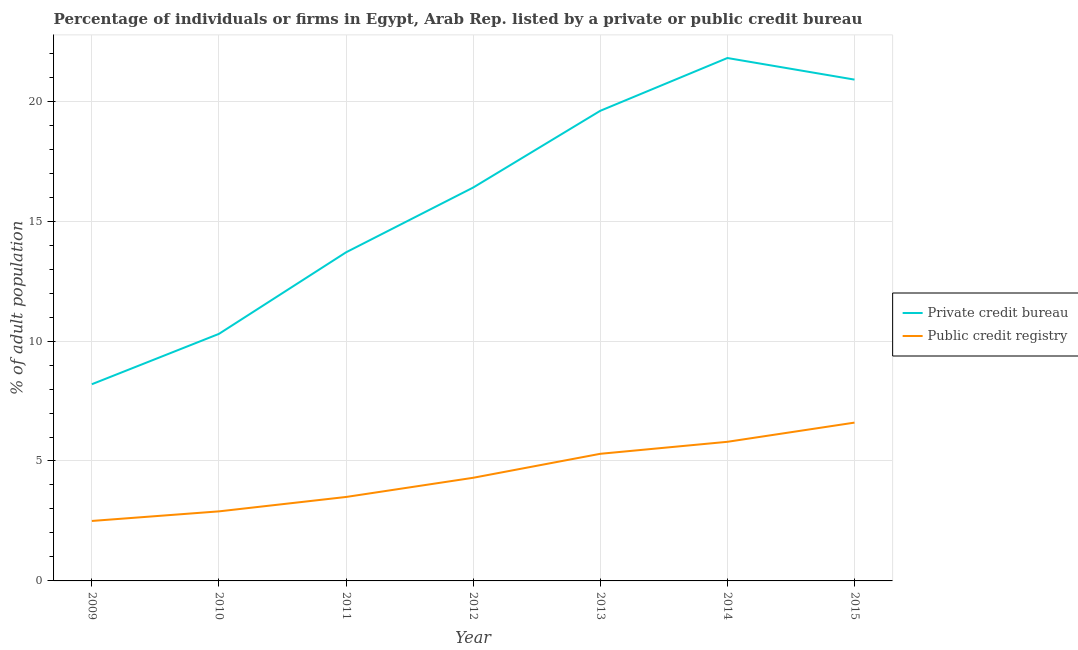Is the number of lines equal to the number of legend labels?
Offer a very short reply. Yes. What is the percentage of firms listed by private credit bureau in 2015?
Ensure brevity in your answer.  20.9. Across all years, what is the maximum percentage of firms listed by private credit bureau?
Your response must be concise. 21.8. In which year was the percentage of firms listed by private credit bureau maximum?
Make the answer very short. 2014. In which year was the percentage of firms listed by private credit bureau minimum?
Your answer should be very brief. 2009. What is the total percentage of firms listed by public credit bureau in the graph?
Provide a succinct answer. 30.9. What is the difference between the percentage of firms listed by private credit bureau in 2009 and the percentage of firms listed by public credit bureau in 2010?
Provide a succinct answer. 5.3. What is the average percentage of firms listed by private credit bureau per year?
Make the answer very short. 15.84. In the year 2010, what is the difference between the percentage of firms listed by private credit bureau and percentage of firms listed by public credit bureau?
Give a very brief answer. 7.4. In how many years, is the percentage of firms listed by public credit bureau greater than 1 %?
Provide a succinct answer. 7. What is the ratio of the percentage of firms listed by private credit bureau in 2014 to that in 2015?
Your answer should be compact. 1.04. Is the difference between the percentage of firms listed by private credit bureau in 2009 and 2015 greater than the difference between the percentage of firms listed by public credit bureau in 2009 and 2015?
Provide a succinct answer. No. What is the difference between the highest and the second highest percentage of firms listed by private credit bureau?
Your answer should be compact. 0.9. What is the difference between the highest and the lowest percentage of firms listed by private credit bureau?
Provide a short and direct response. 13.6. In how many years, is the percentage of firms listed by private credit bureau greater than the average percentage of firms listed by private credit bureau taken over all years?
Your answer should be very brief. 4. Is the percentage of firms listed by private credit bureau strictly greater than the percentage of firms listed by public credit bureau over the years?
Offer a terse response. Yes. Are the values on the major ticks of Y-axis written in scientific E-notation?
Your answer should be very brief. No. Does the graph contain any zero values?
Ensure brevity in your answer.  No. How are the legend labels stacked?
Your answer should be very brief. Vertical. What is the title of the graph?
Offer a very short reply. Percentage of individuals or firms in Egypt, Arab Rep. listed by a private or public credit bureau. What is the label or title of the X-axis?
Offer a terse response. Year. What is the label or title of the Y-axis?
Your answer should be very brief. % of adult population. What is the % of adult population of Private credit bureau in 2009?
Make the answer very short. 8.2. What is the % of adult population in Private credit bureau in 2010?
Ensure brevity in your answer.  10.3. What is the % of adult population in Public credit registry in 2010?
Your answer should be compact. 2.9. What is the % of adult population of Private credit bureau in 2011?
Offer a terse response. 13.7. What is the % of adult population of Private credit bureau in 2012?
Provide a short and direct response. 16.4. What is the % of adult population in Public credit registry in 2012?
Keep it short and to the point. 4.3. What is the % of adult population in Private credit bureau in 2013?
Your response must be concise. 19.6. What is the % of adult population of Private credit bureau in 2014?
Your answer should be very brief. 21.8. What is the % of adult population in Public credit registry in 2014?
Provide a succinct answer. 5.8. What is the % of adult population in Private credit bureau in 2015?
Make the answer very short. 20.9. Across all years, what is the maximum % of adult population in Private credit bureau?
Make the answer very short. 21.8. Across all years, what is the maximum % of adult population of Public credit registry?
Your answer should be very brief. 6.6. What is the total % of adult population in Private credit bureau in the graph?
Offer a terse response. 110.9. What is the total % of adult population of Public credit registry in the graph?
Give a very brief answer. 30.9. What is the difference between the % of adult population of Private credit bureau in 2009 and that in 2011?
Ensure brevity in your answer.  -5.5. What is the difference between the % of adult population of Public credit registry in 2009 and that in 2011?
Provide a succinct answer. -1. What is the difference between the % of adult population in Private credit bureau in 2009 and that in 2012?
Your answer should be very brief. -8.2. What is the difference between the % of adult population in Private credit bureau in 2009 and that in 2014?
Make the answer very short. -13.6. What is the difference between the % of adult population of Private credit bureau in 2009 and that in 2015?
Provide a succinct answer. -12.7. What is the difference between the % of adult population in Public credit registry in 2009 and that in 2015?
Offer a terse response. -4.1. What is the difference between the % of adult population in Private credit bureau in 2010 and that in 2013?
Your response must be concise. -9.3. What is the difference between the % of adult population in Public credit registry in 2010 and that in 2013?
Your answer should be very brief. -2.4. What is the difference between the % of adult population in Public credit registry in 2010 and that in 2015?
Offer a very short reply. -3.7. What is the difference between the % of adult population in Private credit bureau in 2011 and that in 2012?
Offer a terse response. -2.7. What is the difference between the % of adult population of Private credit bureau in 2011 and that in 2013?
Offer a very short reply. -5.9. What is the difference between the % of adult population in Public credit registry in 2011 and that in 2014?
Offer a very short reply. -2.3. What is the difference between the % of adult population of Private credit bureau in 2011 and that in 2015?
Your answer should be very brief. -7.2. What is the difference between the % of adult population in Public credit registry in 2012 and that in 2013?
Give a very brief answer. -1. What is the difference between the % of adult population in Private credit bureau in 2012 and that in 2014?
Provide a short and direct response. -5.4. What is the difference between the % of adult population of Private credit bureau in 2012 and that in 2015?
Provide a short and direct response. -4.5. What is the difference between the % of adult population in Public credit registry in 2012 and that in 2015?
Ensure brevity in your answer.  -2.3. What is the difference between the % of adult population of Private credit bureau in 2013 and that in 2014?
Make the answer very short. -2.2. What is the difference between the % of adult population in Public credit registry in 2013 and that in 2014?
Your answer should be very brief. -0.5. What is the difference between the % of adult population of Private credit bureau in 2013 and that in 2015?
Offer a terse response. -1.3. What is the difference between the % of adult population of Private credit bureau in 2014 and that in 2015?
Offer a very short reply. 0.9. What is the difference between the % of adult population in Public credit registry in 2014 and that in 2015?
Offer a terse response. -0.8. What is the difference between the % of adult population in Private credit bureau in 2009 and the % of adult population in Public credit registry in 2014?
Offer a very short reply. 2.4. What is the difference between the % of adult population in Private credit bureau in 2010 and the % of adult population in Public credit registry in 2013?
Ensure brevity in your answer.  5. What is the difference between the % of adult population in Private credit bureau in 2010 and the % of adult population in Public credit registry in 2014?
Offer a terse response. 4.5. What is the difference between the % of adult population of Private credit bureau in 2010 and the % of adult population of Public credit registry in 2015?
Provide a short and direct response. 3.7. What is the difference between the % of adult population of Private credit bureau in 2011 and the % of adult population of Public credit registry in 2013?
Ensure brevity in your answer.  8.4. What is the difference between the % of adult population of Private credit bureau in 2011 and the % of adult population of Public credit registry in 2014?
Your answer should be very brief. 7.9. What is the difference between the % of adult population of Private credit bureau in 2011 and the % of adult population of Public credit registry in 2015?
Your response must be concise. 7.1. What is the difference between the % of adult population of Private credit bureau in 2012 and the % of adult population of Public credit registry in 2015?
Your answer should be compact. 9.8. What is the difference between the % of adult population in Private credit bureau in 2014 and the % of adult population in Public credit registry in 2015?
Provide a succinct answer. 15.2. What is the average % of adult population in Private credit bureau per year?
Provide a succinct answer. 15.84. What is the average % of adult population in Public credit registry per year?
Make the answer very short. 4.41. In the year 2009, what is the difference between the % of adult population in Private credit bureau and % of adult population in Public credit registry?
Provide a succinct answer. 5.7. In the year 2011, what is the difference between the % of adult population of Private credit bureau and % of adult population of Public credit registry?
Keep it short and to the point. 10.2. In the year 2012, what is the difference between the % of adult population of Private credit bureau and % of adult population of Public credit registry?
Your response must be concise. 12.1. In the year 2013, what is the difference between the % of adult population in Private credit bureau and % of adult population in Public credit registry?
Offer a terse response. 14.3. In the year 2015, what is the difference between the % of adult population in Private credit bureau and % of adult population in Public credit registry?
Keep it short and to the point. 14.3. What is the ratio of the % of adult population in Private credit bureau in 2009 to that in 2010?
Your answer should be compact. 0.8. What is the ratio of the % of adult population in Public credit registry in 2009 to that in 2010?
Give a very brief answer. 0.86. What is the ratio of the % of adult population in Private credit bureau in 2009 to that in 2011?
Ensure brevity in your answer.  0.6. What is the ratio of the % of adult population of Private credit bureau in 2009 to that in 2012?
Your answer should be compact. 0.5. What is the ratio of the % of adult population of Public credit registry in 2009 to that in 2012?
Your response must be concise. 0.58. What is the ratio of the % of adult population of Private credit bureau in 2009 to that in 2013?
Offer a very short reply. 0.42. What is the ratio of the % of adult population of Public credit registry in 2009 to that in 2013?
Your answer should be very brief. 0.47. What is the ratio of the % of adult population in Private credit bureau in 2009 to that in 2014?
Provide a short and direct response. 0.38. What is the ratio of the % of adult population of Public credit registry in 2009 to that in 2014?
Your answer should be compact. 0.43. What is the ratio of the % of adult population of Private credit bureau in 2009 to that in 2015?
Keep it short and to the point. 0.39. What is the ratio of the % of adult population of Public credit registry in 2009 to that in 2015?
Provide a short and direct response. 0.38. What is the ratio of the % of adult population in Private credit bureau in 2010 to that in 2011?
Offer a terse response. 0.75. What is the ratio of the % of adult population in Public credit registry in 2010 to that in 2011?
Your response must be concise. 0.83. What is the ratio of the % of adult population of Private credit bureau in 2010 to that in 2012?
Provide a short and direct response. 0.63. What is the ratio of the % of adult population in Public credit registry in 2010 to that in 2012?
Ensure brevity in your answer.  0.67. What is the ratio of the % of adult population in Private credit bureau in 2010 to that in 2013?
Offer a very short reply. 0.53. What is the ratio of the % of adult population in Public credit registry in 2010 to that in 2013?
Ensure brevity in your answer.  0.55. What is the ratio of the % of adult population of Private credit bureau in 2010 to that in 2014?
Offer a very short reply. 0.47. What is the ratio of the % of adult population in Private credit bureau in 2010 to that in 2015?
Your response must be concise. 0.49. What is the ratio of the % of adult population in Public credit registry in 2010 to that in 2015?
Provide a short and direct response. 0.44. What is the ratio of the % of adult population in Private credit bureau in 2011 to that in 2012?
Ensure brevity in your answer.  0.84. What is the ratio of the % of adult population of Public credit registry in 2011 to that in 2012?
Offer a very short reply. 0.81. What is the ratio of the % of adult population of Private credit bureau in 2011 to that in 2013?
Make the answer very short. 0.7. What is the ratio of the % of adult population of Public credit registry in 2011 to that in 2013?
Offer a terse response. 0.66. What is the ratio of the % of adult population of Private credit bureau in 2011 to that in 2014?
Give a very brief answer. 0.63. What is the ratio of the % of adult population in Public credit registry in 2011 to that in 2014?
Your response must be concise. 0.6. What is the ratio of the % of adult population of Private credit bureau in 2011 to that in 2015?
Offer a very short reply. 0.66. What is the ratio of the % of adult population in Public credit registry in 2011 to that in 2015?
Your answer should be compact. 0.53. What is the ratio of the % of adult population of Private credit bureau in 2012 to that in 2013?
Provide a short and direct response. 0.84. What is the ratio of the % of adult population in Public credit registry in 2012 to that in 2013?
Your answer should be very brief. 0.81. What is the ratio of the % of adult population in Private credit bureau in 2012 to that in 2014?
Your response must be concise. 0.75. What is the ratio of the % of adult population in Public credit registry in 2012 to that in 2014?
Your answer should be compact. 0.74. What is the ratio of the % of adult population of Private credit bureau in 2012 to that in 2015?
Ensure brevity in your answer.  0.78. What is the ratio of the % of adult population of Public credit registry in 2012 to that in 2015?
Give a very brief answer. 0.65. What is the ratio of the % of adult population of Private credit bureau in 2013 to that in 2014?
Provide a short and direct response. 0.9. What is the ratio of the % of adult population in Public credit registry in 2013 to that in 2014?
Make the answer very short. 0.91. What is the ratio of the % of adult population in Private credit bureau in 2013 to that in 2015?
Your answer should be compact. 0.94. What is the ratio of the % of adult population in Public credit registry in 2013 to that in 2015?
Offer a terse response. 0.8. What is the ratio of the % of adult population of Private credit bureau in 2014 to that in 2015?
Keep it short and to the point. 1.04. What is the ratio of the % of adult population of Public credit registry in 2014 to that in 2015?
Offer a very short reply. 0.88. What is the difference between the highest and the second highest % of adult population in Private credit bureau?
Give a very brief answer. 0.9. What is the difference between the highest and the lowest % of adult population of Private credit bureau?
Keep it short and to the point. 13.6. What is the difference between the highest and the lowest % of adult population in Public credit registry?
Keep it short and to the point. 4.1. 